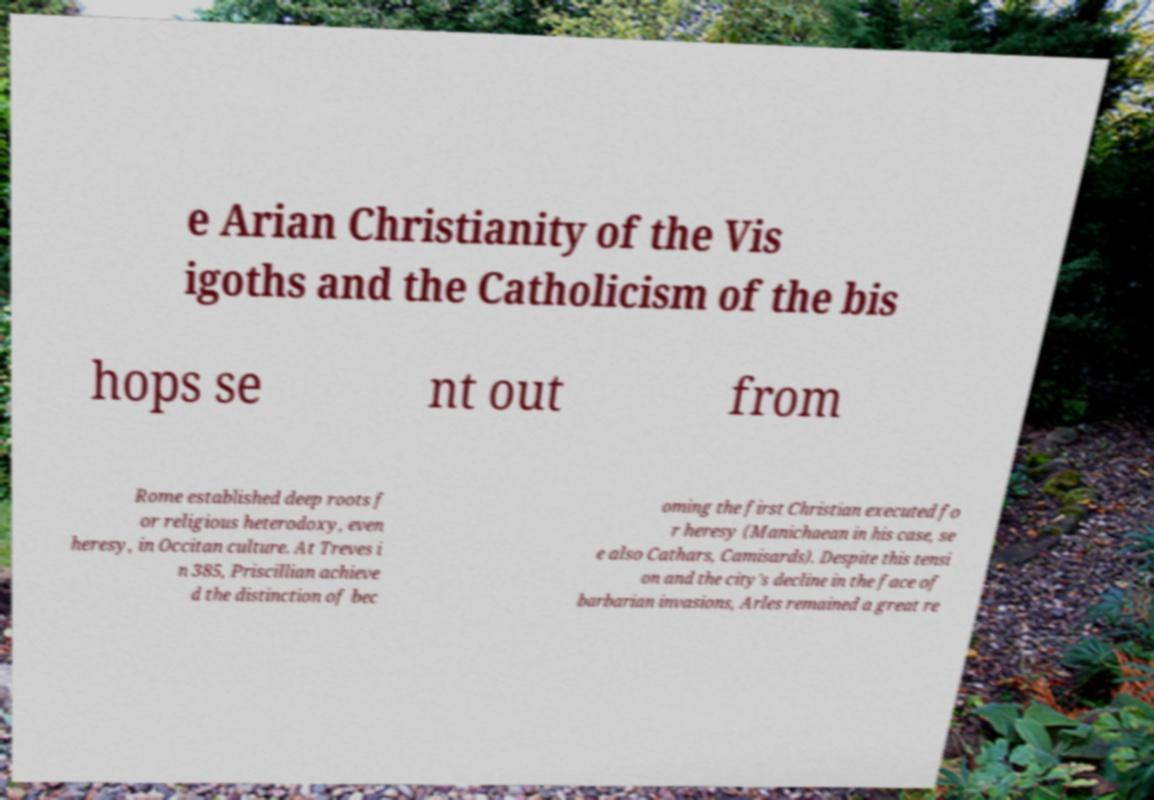Can you read and provide the text displayed in the image?This photo seems to have some interesting text. Can you extract and type it out for me? e Arian Christianity of the Vis igoths and the Catholicism of the bis hops se nt out from Rome established deep roots f or religious heterodoxy, even heresy, in Occitan culture. At Treves i n 385, Priscillian achieve d the distinction of bec oming the first Christian executed fo r heresy (Manichaean in his case, se e also Cathars, Camisards). Despite this tensi on and the city's decline in the face of barbarian invasions, Arles remained a great re 